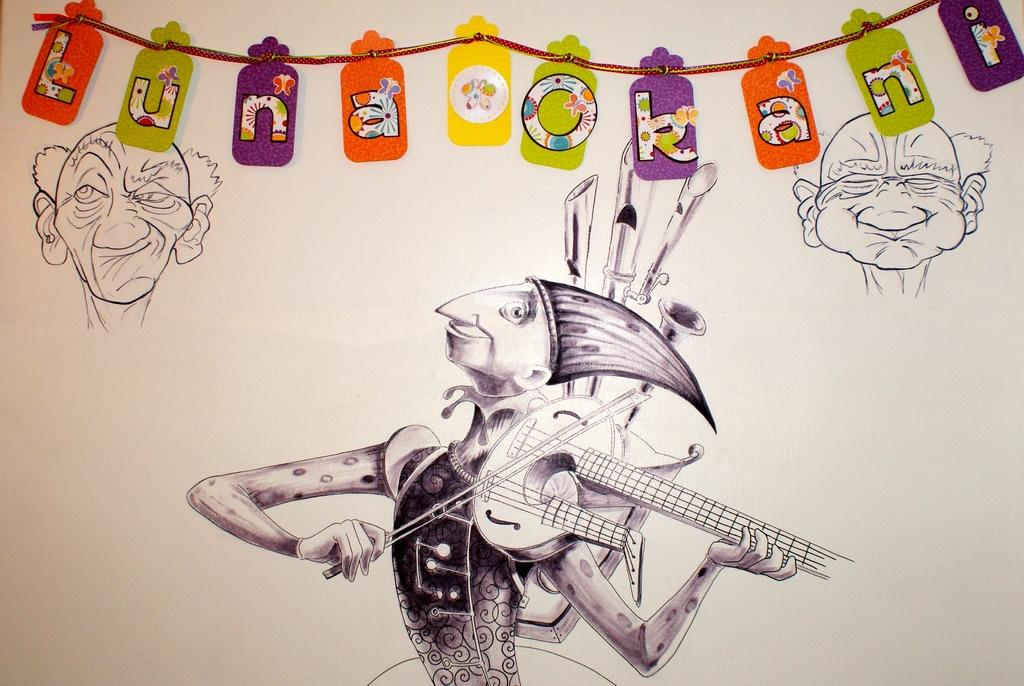What is present on the wall in the image? There is a painting of persons on the wall in the image. What else can be seen on the wall besides the painting? There are decorative items at the top of the wall in the image. What number is written on the painting? There is no number written on the painting in the image. 